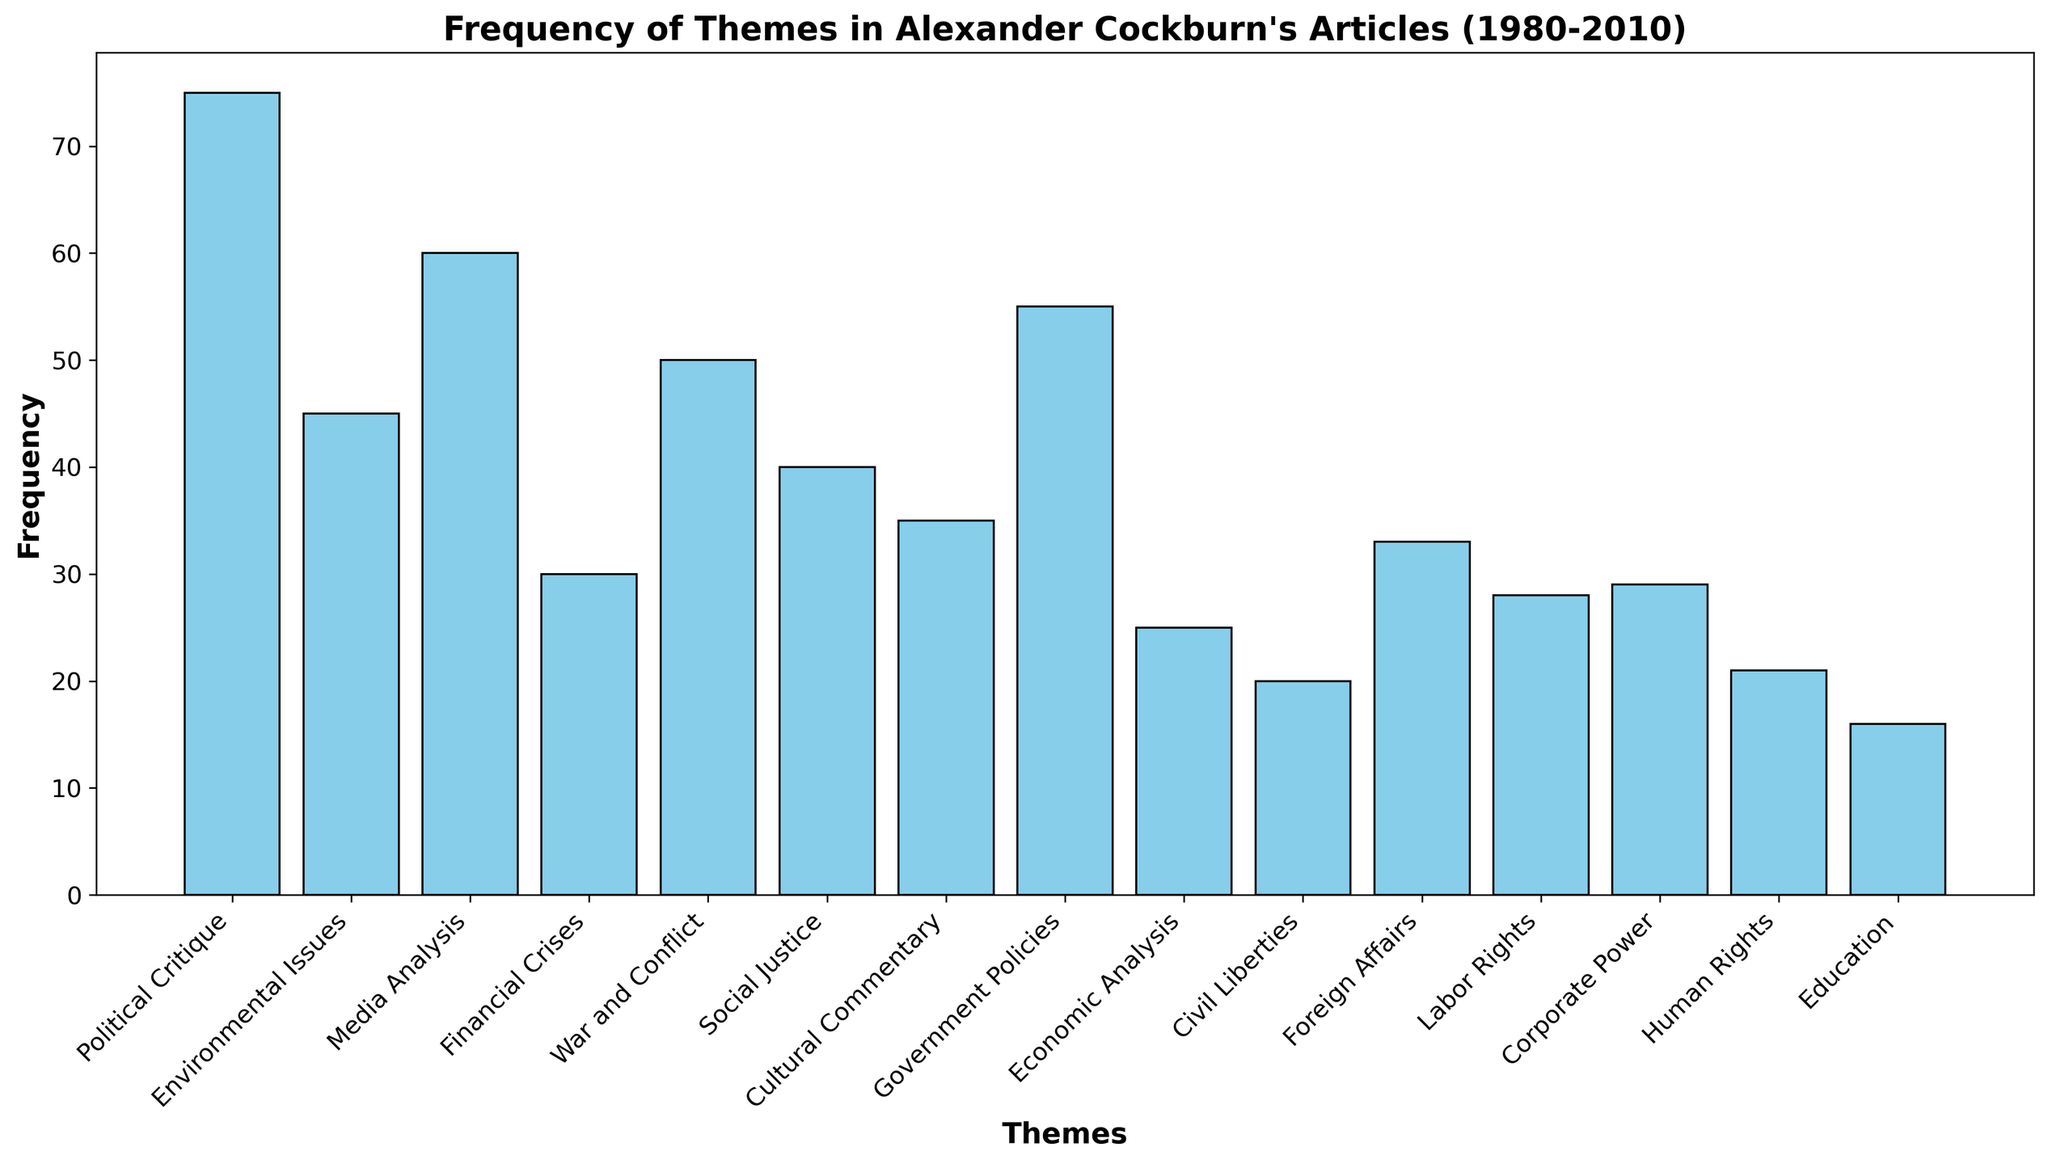What is the most frequently discussed theme in Alexander Cockburn's articles? The bar chart shows the frequency of each theme. The highest bar represents the most frequently discussed theme. By observing the chart, we can see that the "Political Critique" bar is the highest, indicating it is the most frequently discussed theme.
Answer: Political Critique Which theme has the lowest frequency, and what is its value? The shortest bar in the chart indicates the theme with the lowest frequency. Observing the chart, the "Education" theme has the shortest bar. The frequency value for this theme is 16.
Answer: Education, 16 How much more frequently does "Political Critique" appear compared to "Environmental Issues"? To determine the difference, we need to subtract the frequency of "Environmental Issues" from that of "Political Critique". The frequency of "Political Critique" is 75, and "Environmental Issues" is 45. The difference is 75 - 45 = 30.
Answer: 30 What is the combined frequency of "Media Analysis", "War and Conflict", and "Government Policies"? We sum the frequencies of the three themes. "Media Analysis" has a frequency of 60, "War and Conflict" has 50, and "Government Policies" has 55. Hence, the combined frequency is 60 + 50 + 55 = 165.
Answer: 165 Are "Economic Analysis" and "Civil Liberties" discussed with the same frequency? By comparing the heights of the bars for "Economic Analysis" and "Civil Liberties," we can determine if their frequencies are equal. "Economic Analysis" has a frequency of 25, and "Civil Liberties" has a frequency of 20, so they are not discussed with the same frequency.
Answer: No Which theme is more frequently discussed: "Corporate Power" or "Foreign Affairs"? We compare the heights of the bars for "Corporate Power" and "Foreign Affairs." The "Corporate Power" bar reaches a frequency of 29, while "Foreign Affairs" reaches 33. Thus, "Foreign Affairs" is more frequently discussed.
Answer: Foreign Affairs Calculate the average frequency of the themes "Social Justice", "Cultural Commentary", and "Human Rights". First, sum the frequencies of the three themes. "Social Justice" has a frequency of 40, "Cultural Commentary" has 35, and "Human Rights" has 21. The total frequency is 40 + 35 + 21 = 96. Then, divide by the number of themes: 96 / 3 = 32.
Answer: 32 Which themes have a frequency higher than 50? By examining the chart, we can identify the bars taller than the value corresponding to 50. The themes with frequencies higher than 50 are "Political Critique" (75), "Media Analysis" (60), and "Government Policies" (55).
Answer: Political Critique, Media Analysis, Government Policies What is the frequency difference between the most and least discussed themes? The most frequently discussed theme is "Political Critique" with a frequency of 75, and the least is "Education" with a frequency of 16. The difference is 75 - 16 = 59.
Answer: 59 